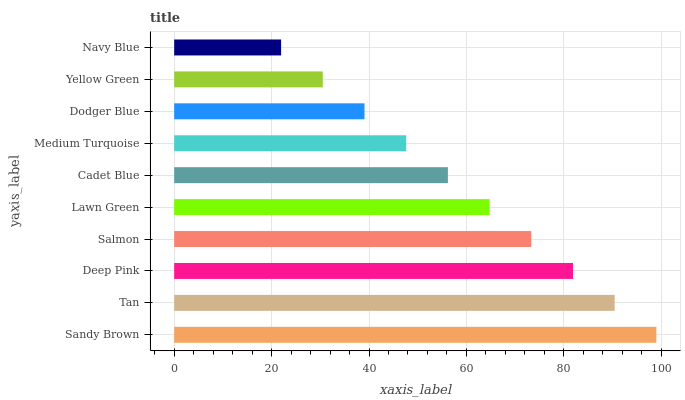Is Navy Blue the minimum?
Answer yes or no. Yes. Is Sandy Brown the maximum?
Answer yes or no. Yes. Is Tan the minimum?
Answer yes or no. No. Is Tan the maximum?
Answer yes or no. No. Is Sandy Brown greater than Tan?
Answer yes or no. Yes. Is Tan less than Sandy Brown?
Answer yes or no. Yes. Is Tan greater than Sandy Brown?
Answer yes or no. No. Is Sandy Brown less than Tan?
Answer yes or no. No. Is Lawn Green the high median?
Answer yes or no. Yes. Is Cadet Blue the low median?
Answer yes or no. Yes. Is Sandy Brown the high median?
Answer yes or no. No. Is Yellow Green the low median?
Answer yes or no. No. 